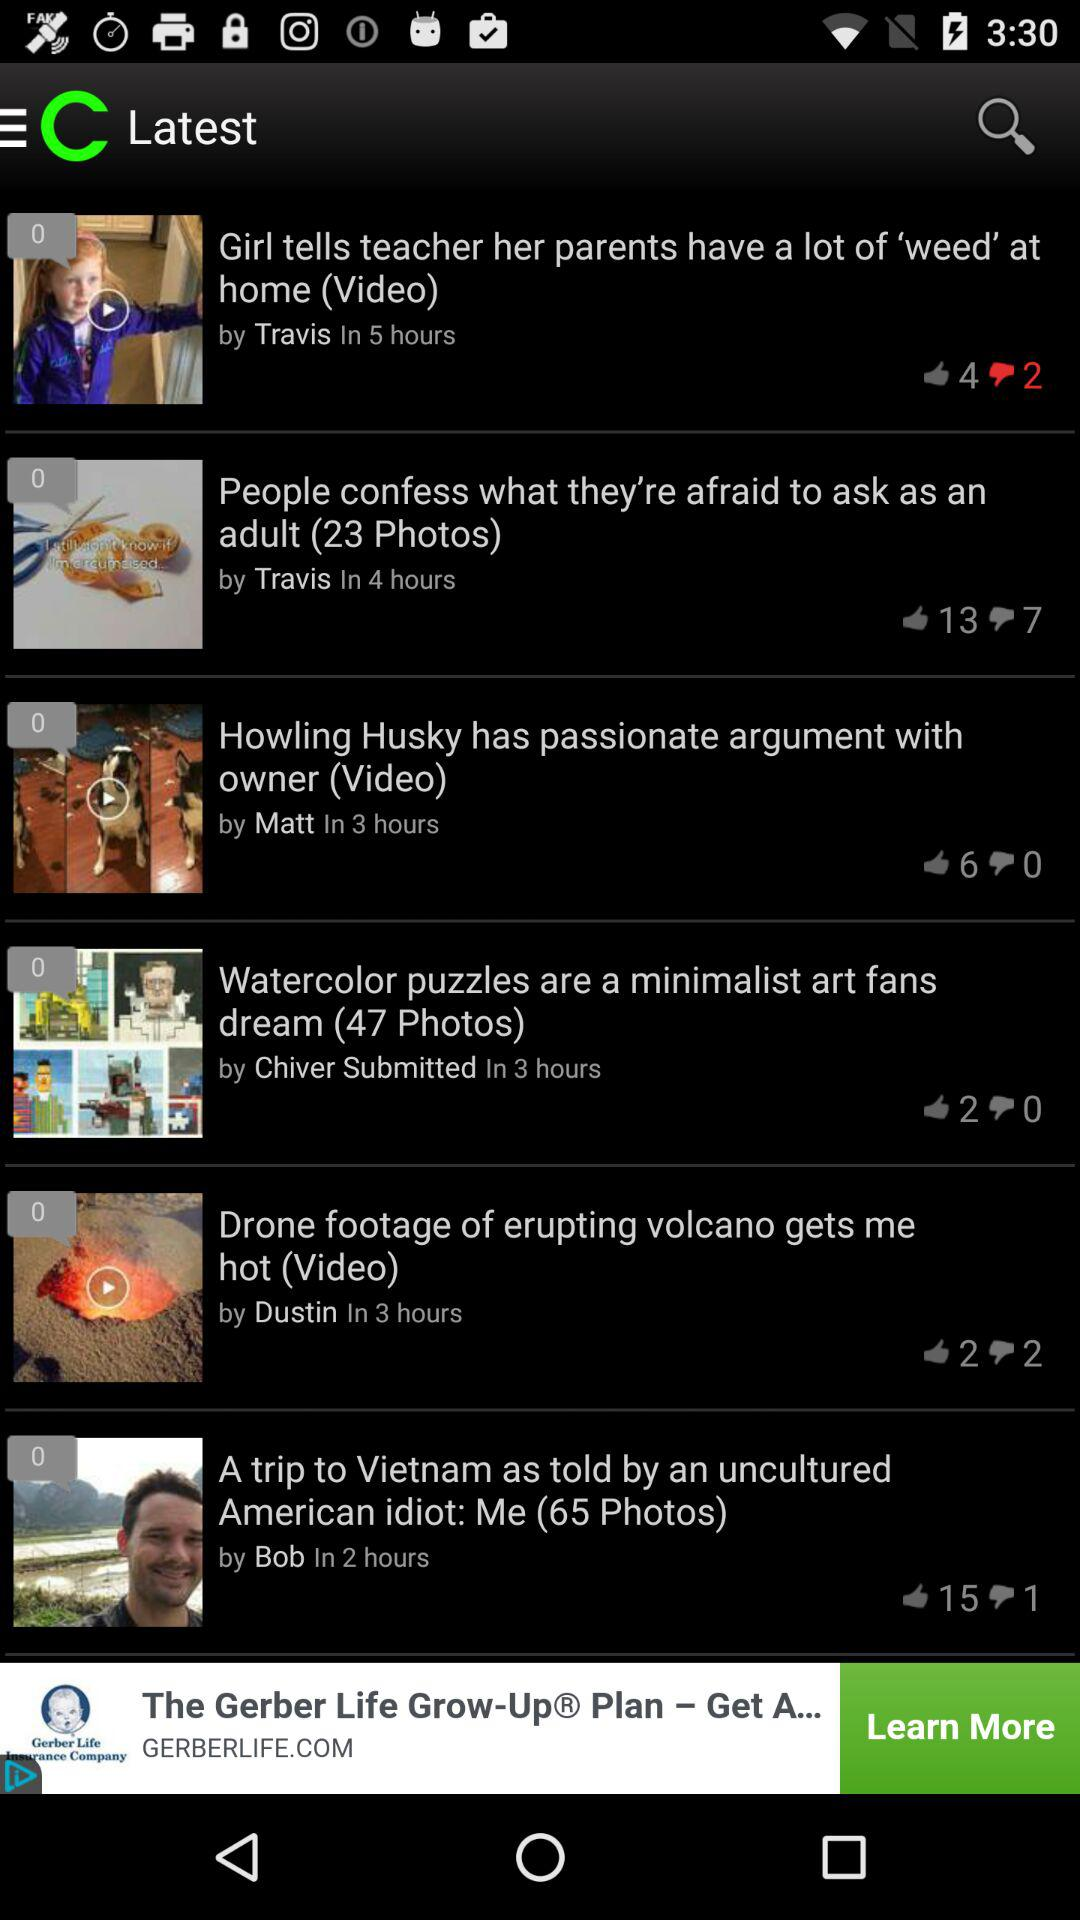How many likes did "Watercolor puzzles are a minimalist art fans dream" get? "Watercolor puzzles are a minimalist art fans dream" got 2 likes. 